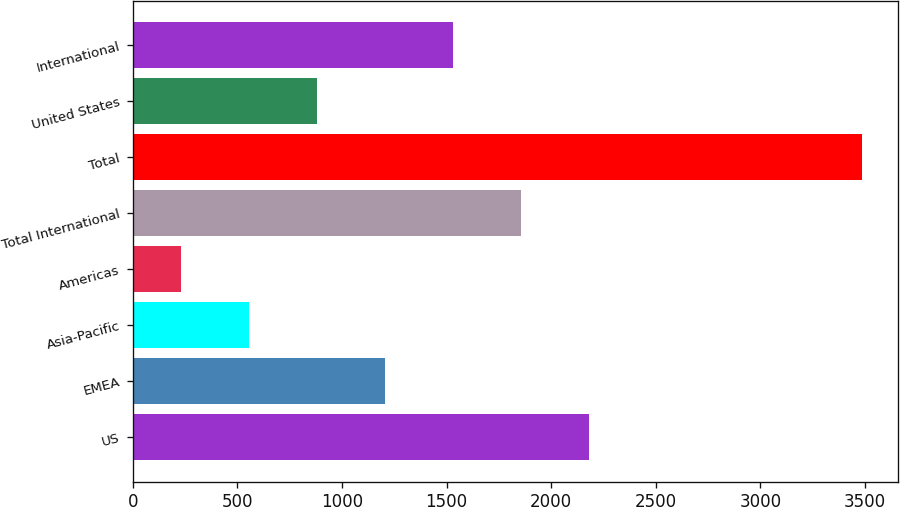Convert chart to OTSL. <chart><loc_0><loc_0><loc_500><loc_500><bar_chart><fcel>US<fcel>EMEA<fcel>Asia-Pacific<fcel>Americas<fcel>Total International<fcel>Total<fcel>United States<fcel>International<nl><fcel>2182.3<fcel>1205.65<fcel>554.55<fcel>229<fcel>1856.75<fcel>3484.5<fcel>880.1<fcel>1531.2<nl></chart> 